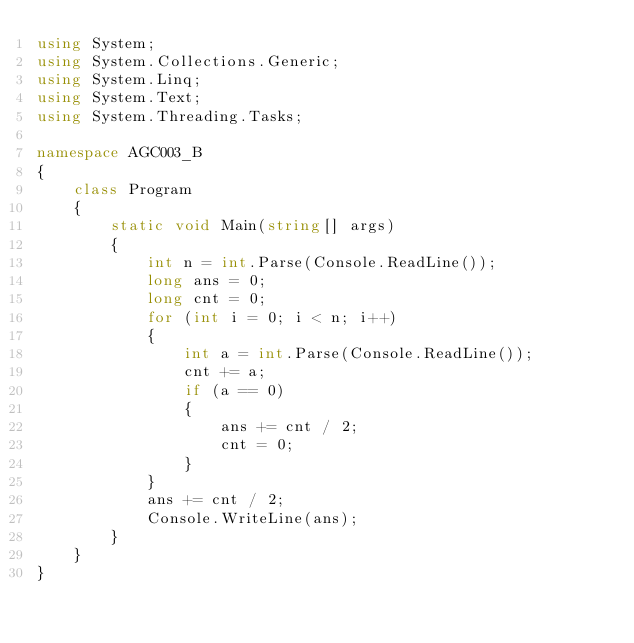<code> <loc_0><loc_0><loc_500><loc_500><_C#_>using System;
using System.Collections.Generic;
using System.Linq;
using System.Text;
using System.Threading.Tasks;

namespace AGC003_B
{
    class Program
    {
        static void Main(string[] args)
        {
            int n = int.Parse(Console.ReadLine());
            long ans = 0;
            long cnt = 0;
            for (int i = 0; i < n; i++)
            {
                int a = int.Parse(Console.ReadLine());
                cnt += a;
                if (a == 0)
                {
                    ans += cnt / 2;
                    cnt = 0;
                }
            }
            ans += cnt / 2;
            Console.WriteLine(ans);
        }
    }
}
</code> 